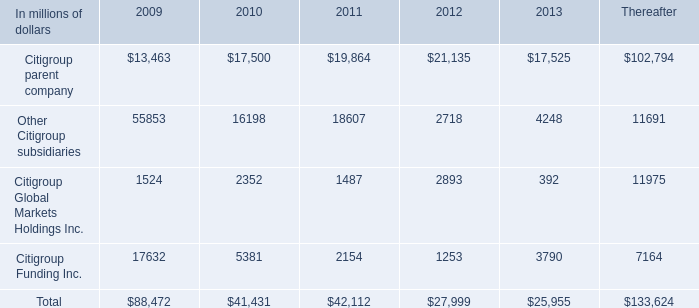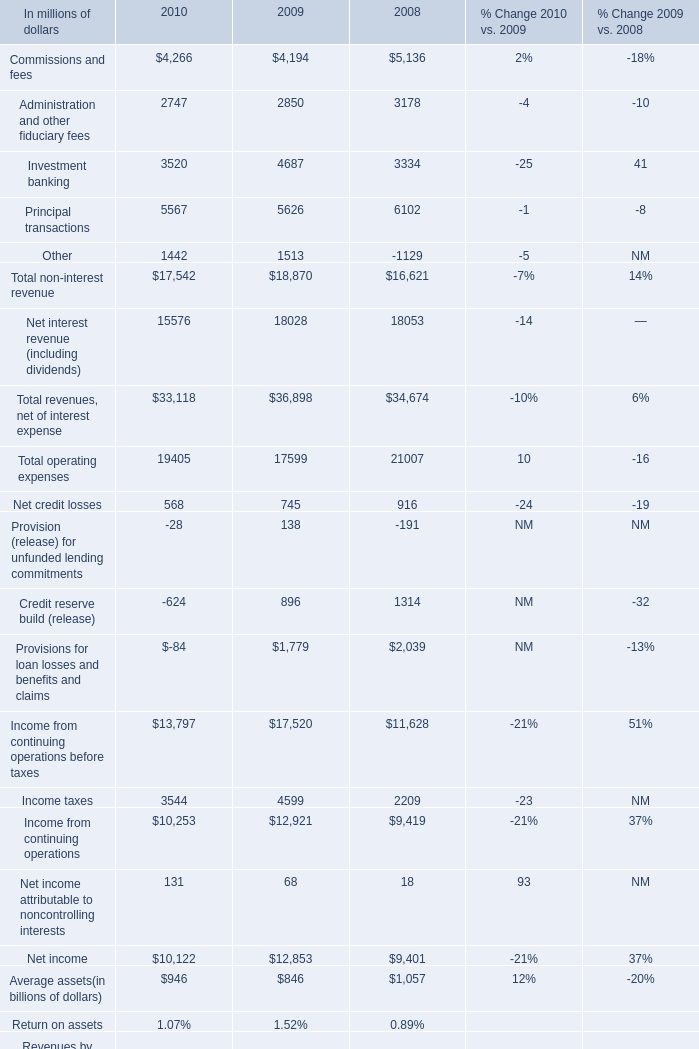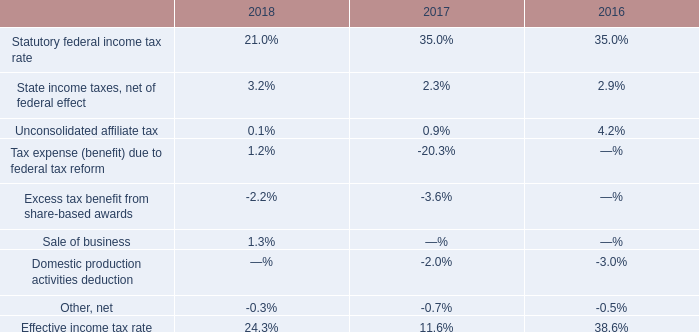What's the average of Other Citigroup subsidiaries of 2012, and Latin America Income from continuing operations by region of 2008 ? 
Computations: ((2718.0 + 1701.0) / 2)
Answer: 2209.5. 